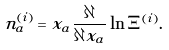Convert formula to latex. <formula><loc_0><loc_0><loc_500><loc_500>n _ { a } ^ { ( i ) } = x _ { a } \frac { \partial } { \partial x _ { a } } \ln \Xi ^ { ( i ) } .</formula> 